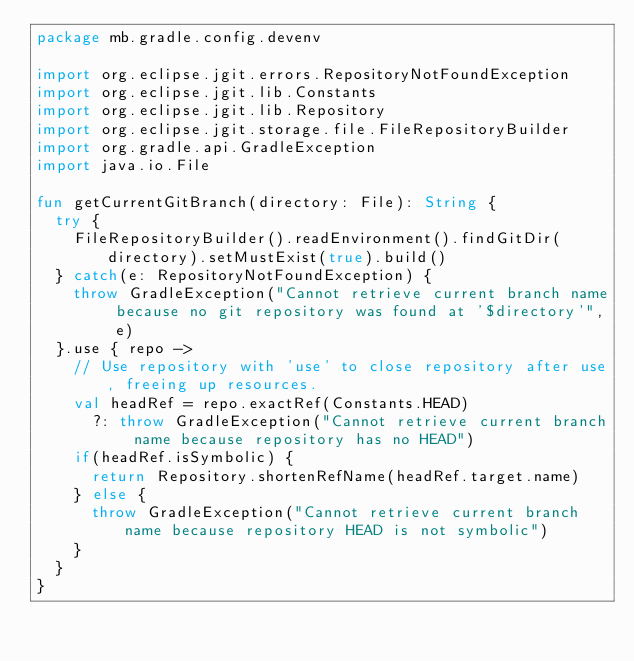Convert code to text. <code><loc_0><loc_0><loc_500><loc_500><_Kotlin_>package mb.gradle.config.devenv

import org.eclipse.jgit.errors.RepositoryNotFoundException
import org.eclipse.jgit.lib.Constants
import org.eclipse.jgit.lib.Repository
import org.eclipse.jgit.storage.file.FileRepositoryBuilder
import org.gradle.api.GradleException
import java.io.File

fun getCurrentGitBranch(directory: File): String {
  try {
    FileRepositoryBuilder().readEnvironment().findGitDir(directory).setMustExist(true).build()
  } catch(e: RepositoryNotFoundException) {
    throw GradleException("Cannot retrieve current branch name because no git repository was found at '$directory'", e)
  }.use { repo ->
    // Use repository with 'use' to close repository after use, freeing up resources.
    val headRef = repo.exactRef(Constants.HEAD)
      ?: throw GradleException("Cannot retrieve current branch name because repository has no HEAD")
    if(headRef.isSymbolic) {
      return Repository.shortenRefName(headRef.target.name)
    } else {
      throw GradleException("Cannot retrieve current branch name because repository HEAD is not symbolic")
    }
  }
}
</code> 